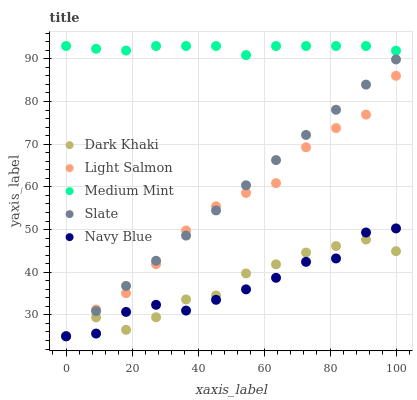Does Navy Blue have the minimum area under the curve?
Answer yes or no. Yes. Does Medium Mint have the maximum area under the curve?
Answer yes or no. Yes. Does Light Salmon have the minimum area under the curve?
Answer yes or no. No. Does Light Salmon have the maximum area under the curve?
Answer yes or no. No. Is Slate the smoothest?
Answer yes or no. Yes. Is Dark Khaki the roughest?
Answer yes or no. Yes. Is Medium Mint the smoothest?
Answer yes or no. No. Is Medium Mint the roughest?
Answer yes or no. No. Does Dark Khaki have the lowest value?
Answer yes or no. Yes. Does Medium Mint have the lowest value?
Answer yes or no. No. Does Medium Mint have the highest value?
Answer yes or no. Yes. Does Light Salmon have the highest value?
Answer yes or no. No. Is Dark Khaki less than Medium Mint?
Answer yes or no. Yes. Is Medium Mint greater than Slate?
Answer yes or no. Yes. Does Dark Khaki intersect Light Salmon?
Answer yes or no. Yes. Is Dark Khaki less than Light Salmon?
Answer yes or no. No. Is Dark Khaki greater than Light Salmon?
Answer yes or no. No. Does Dark Khaki intersect Medium Mint?
Answer yes or no. No. 